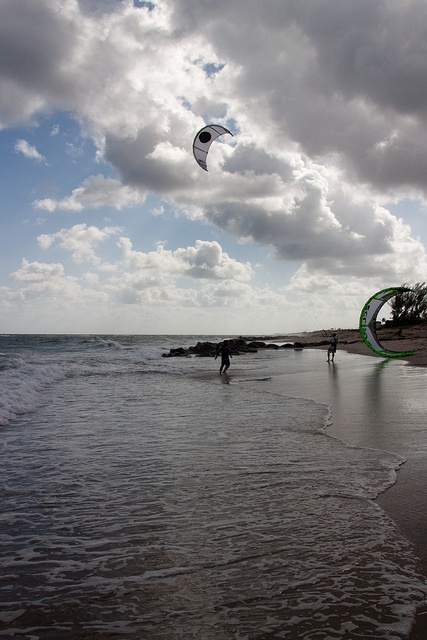Describe the objects in this image and their specific colors. I can see kite in gray, black, and darkgreen tones, kite in gray and black tones, people in gray and black tones, and people in gray, black, and darkgray tones in this image. 